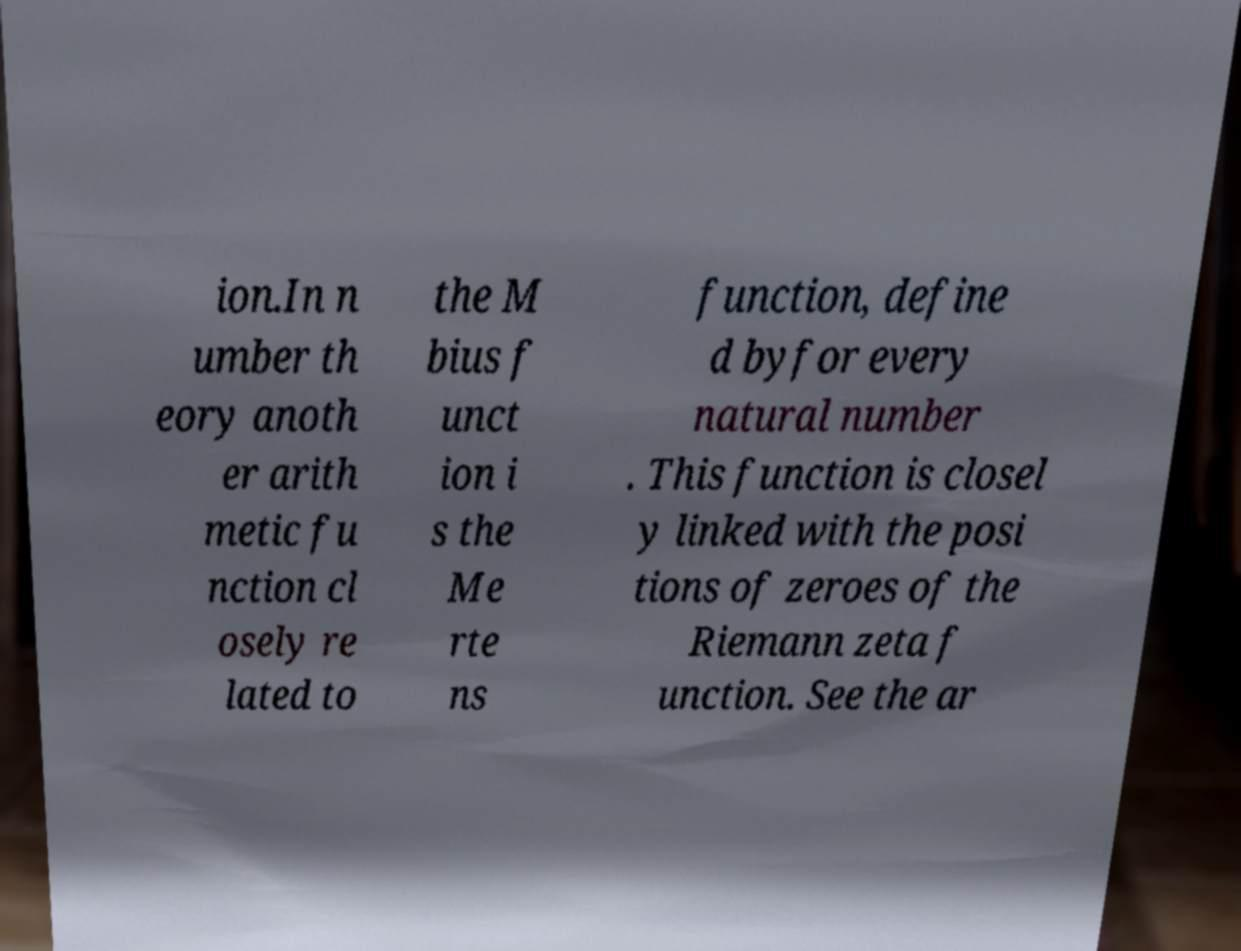Please identify and transcribe the text found in this image. ion.In n umber th eory anoth er arith metic fu nction cl osely re lated to the M bius f unct ion i s the Me rte ns function, define d byfor every natural number . This function is closel y linked with the posi tions of zeroes of the Riemann zeta f unction. See the ar 